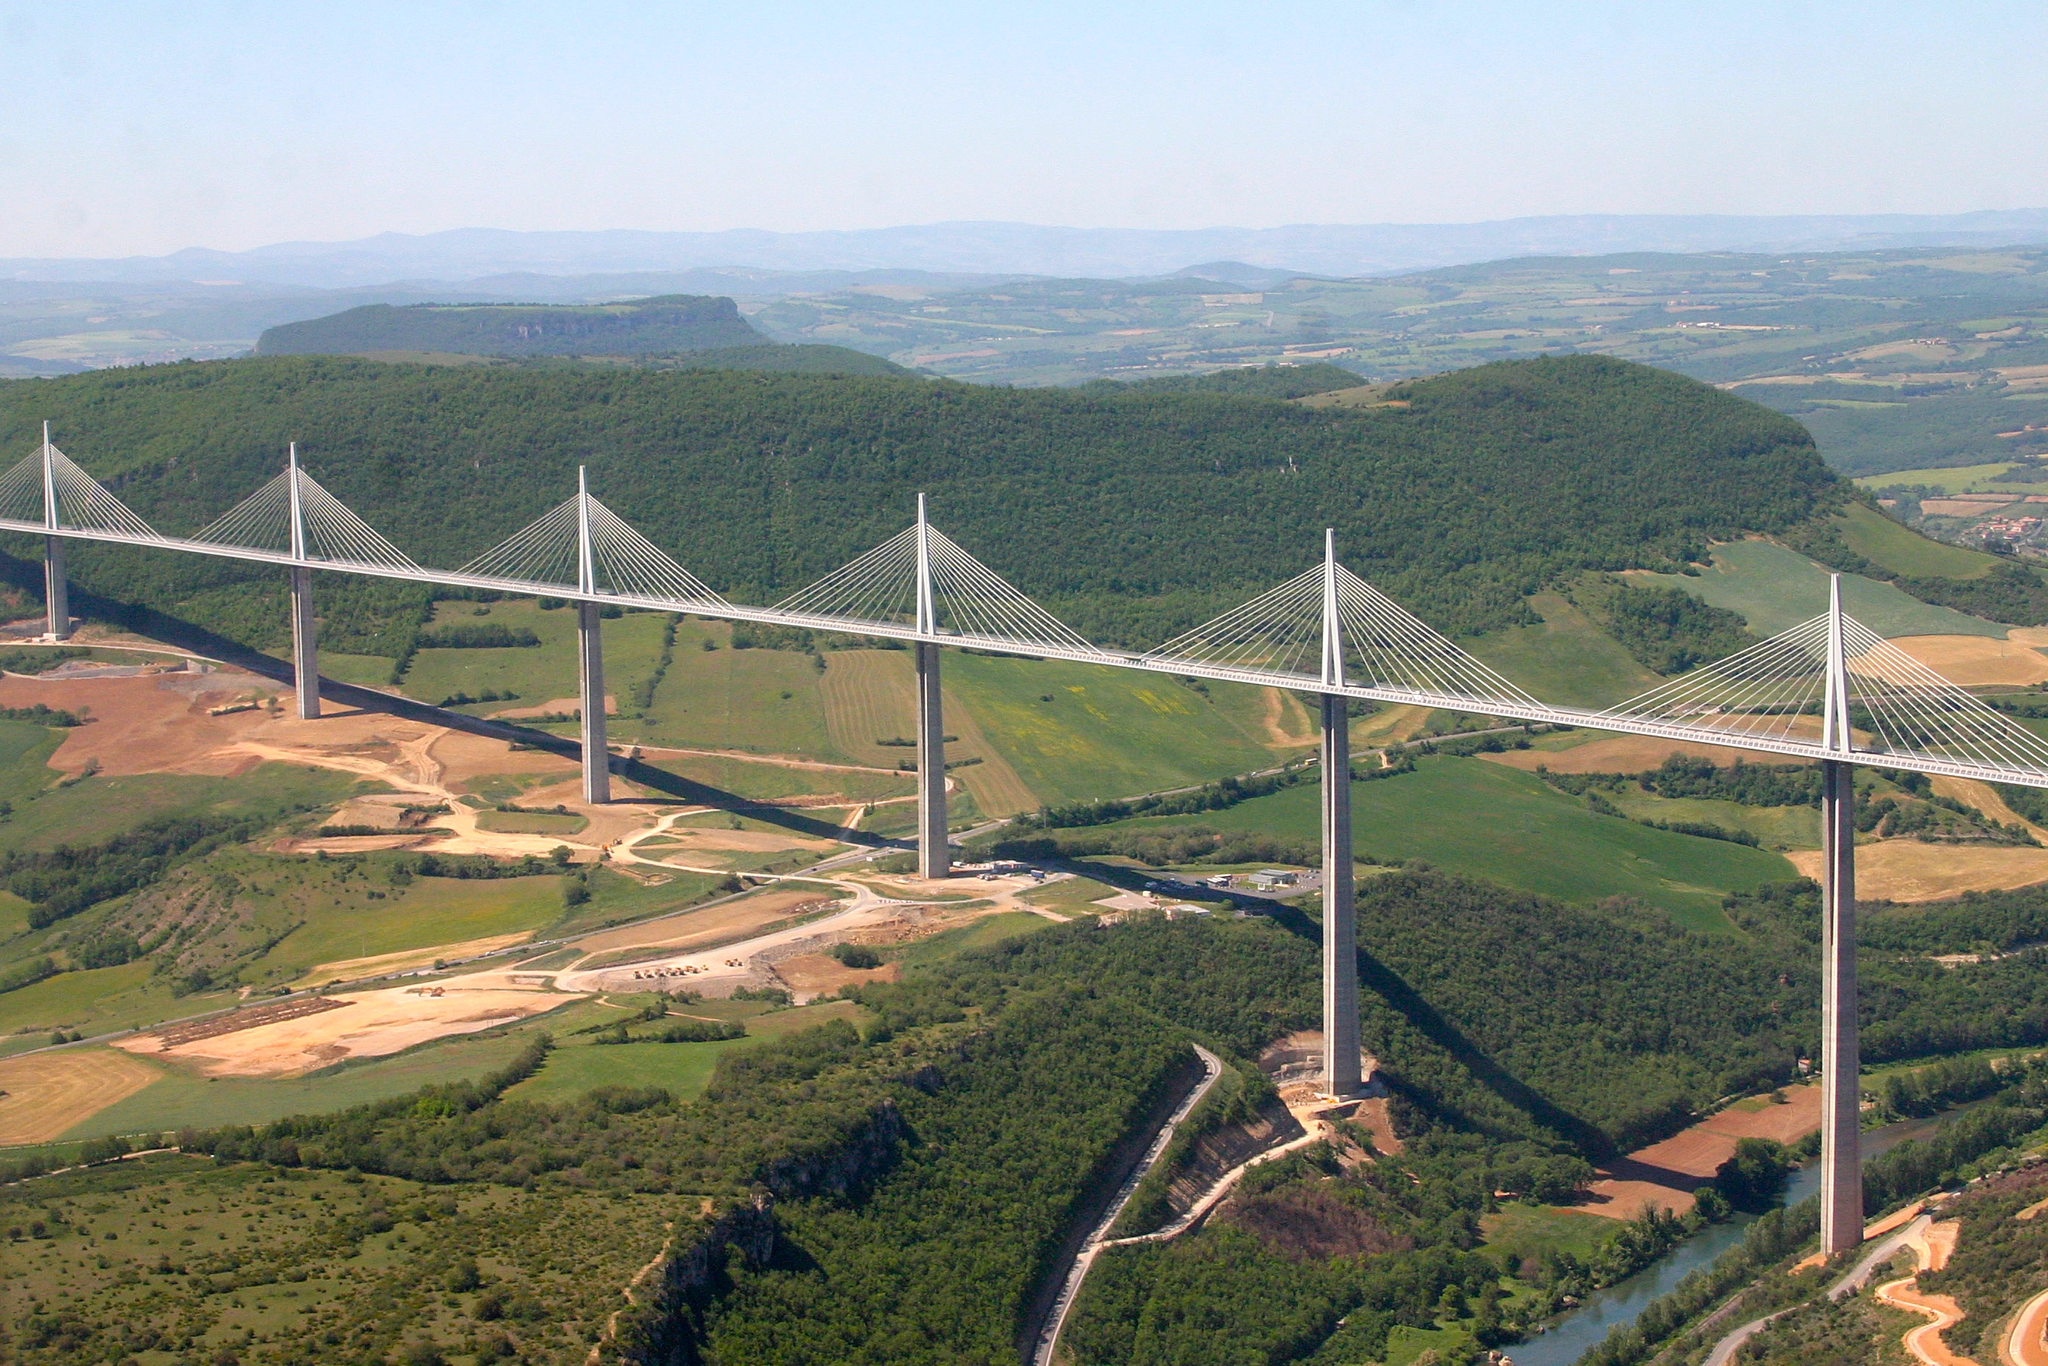Can you discuss any unique architectural features of the Millau Viaduct? One of the most striking architectural features of the Millau Viaduct is its multi-stayed cables, an engineering choice that not only supports the roadway but provides a visually striking aesthetic against the sky. Each of the seven pylons is streamlined, minimizing wind resistance and blending the structure aesthetically with its surroundings. Moreover, the slightly transparent railing and the light-colored pavement reduce visual intrusion, offering drivers and observers alike a seemingly floating passage across the valley. 